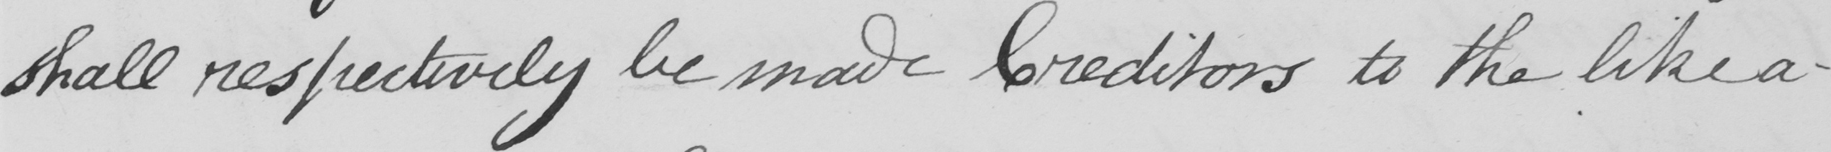Please provide the text content of this handwritten line. shall respectively be made Creditors to the like a- 